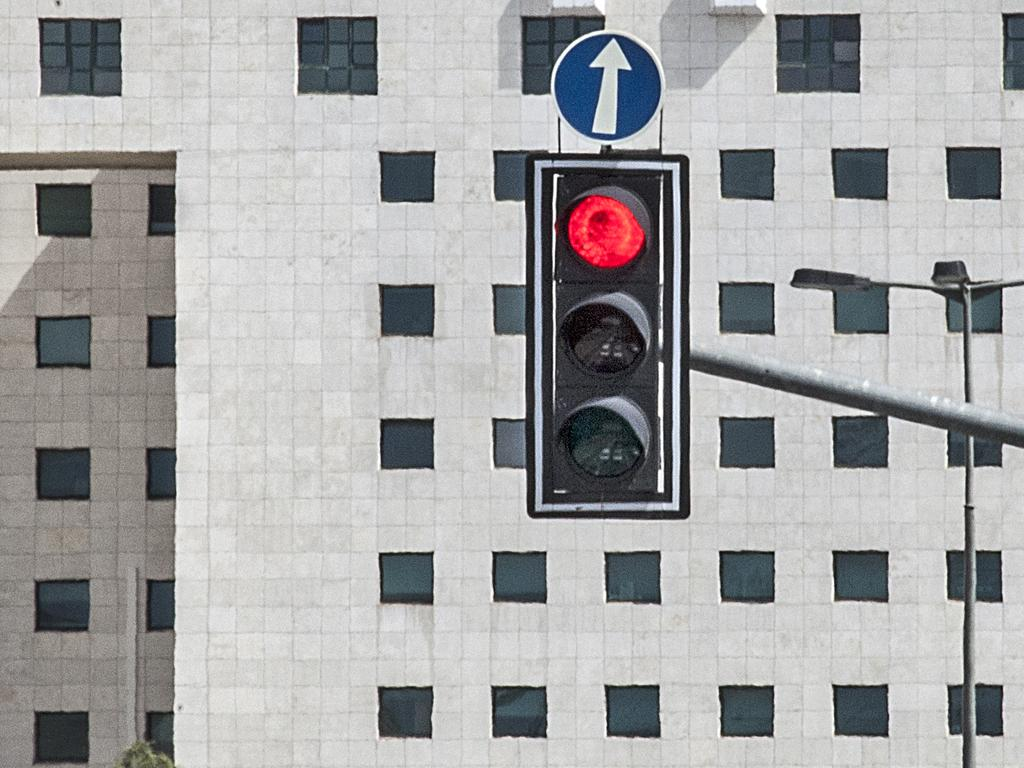What type of object is present in the image that regulates traffic? There is a traffic signal light in the image. What other object can be seen in the image that provides information? There is a signboard in the image. What is the tall, vertical object in the image? There is a pole in the image. What can be seen in the background of the image? There is a building with windows in the background of the image. Can you see the goose taking a breath in the image? There is no goose present in the image, so it is not possible to see a goose taking a breath. 